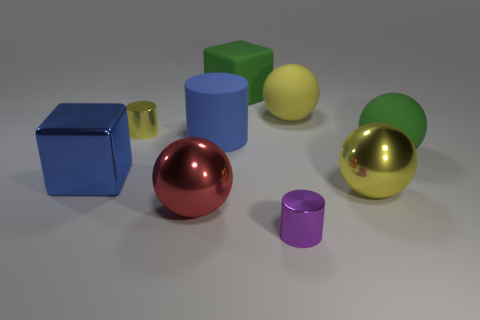Subtract all shiny cylinders. How many cylinders are left? 1 Subtract all blue cubes. How many cubes are left? 1 Subtract all cylinders. How many objects are left? 6 Subtract 4 spheres. How many spheres are left? 0 Subtract all red blocks. Subtract all brown balls. How many blocks are left? 2 Subtract all yellow cylinders. How many green cubes are left? 1 Subtract all big blue metallic things. Subtract all large cylinders. How many objects are left? 7 Add 6 big red metal objects. How many big red metal objects are left? 7 Add 4 cubes. How many cubes exist? 6 Subtract 0 green cylinders. How many objects are left? 9 